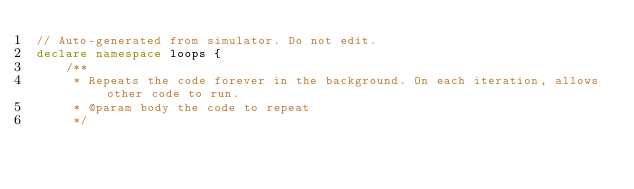<code> <loc_0><loc_0><loc_500><loc_500><_TypeScript_>// Auto-generated from simulator. Do not edit.
declare namespace loops {
    /**
     * Repeats the code forever in the background. On each iteration, allows other code to run.
     * @param body the code to repeat
     */</code> 